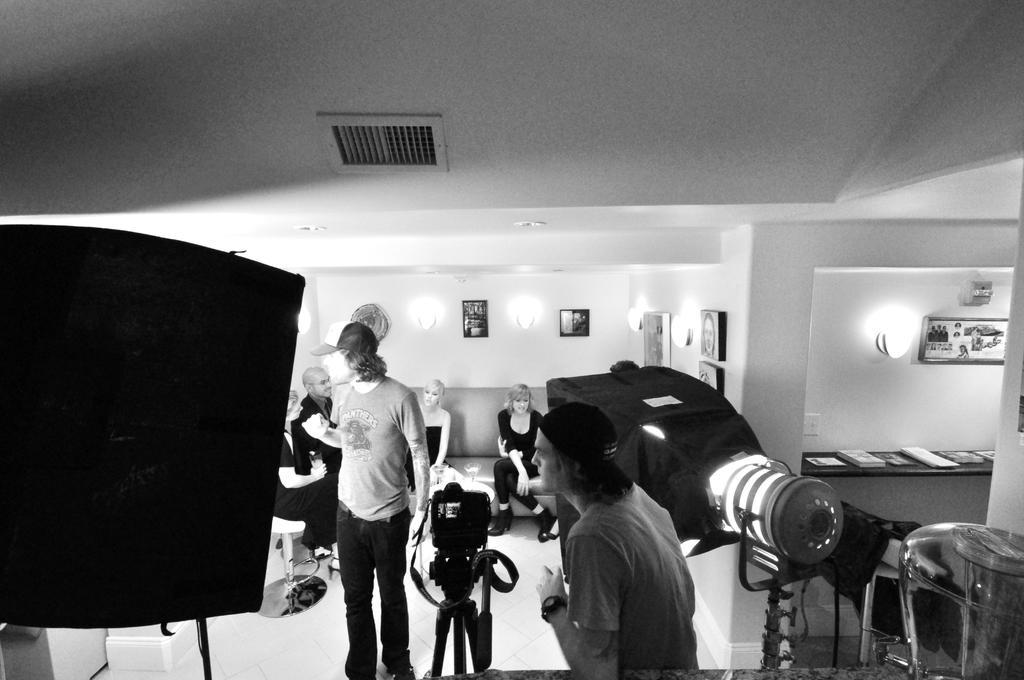Could you give a brief overview of what you see in this image? In this picture there is a man who is wearing watch, t-shirt and cap. He is standing near to the camera and light. At the bottom we can see another man who is wearing cap, t-shirt and jeans. He is standing near to the chair. On the couch we can see the people were sitting. Behind that we can see a light, photo frames. At the top there is an exhaust duct. On the right we can see the table and chairs. On the table we can see many books. 